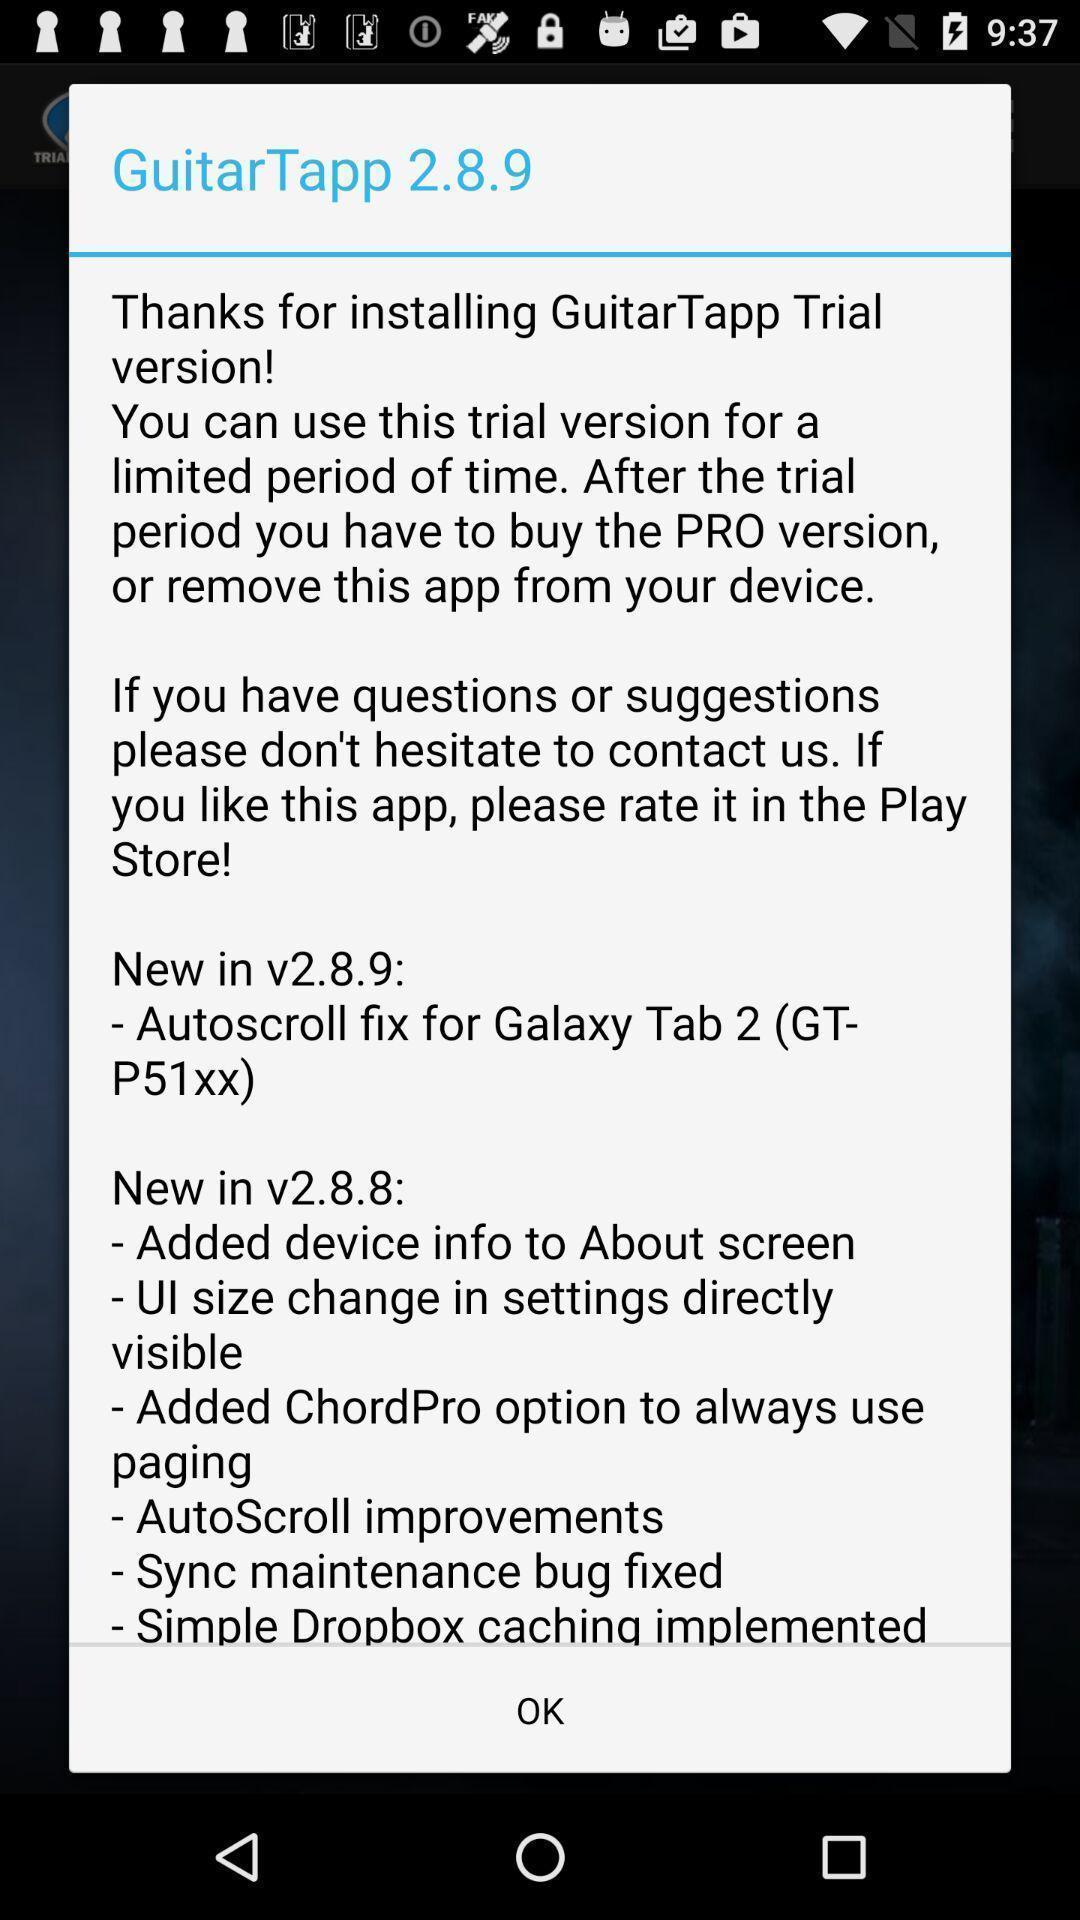Summarize the main components in this picture. Popup of the text in the application regarding welcome text. 